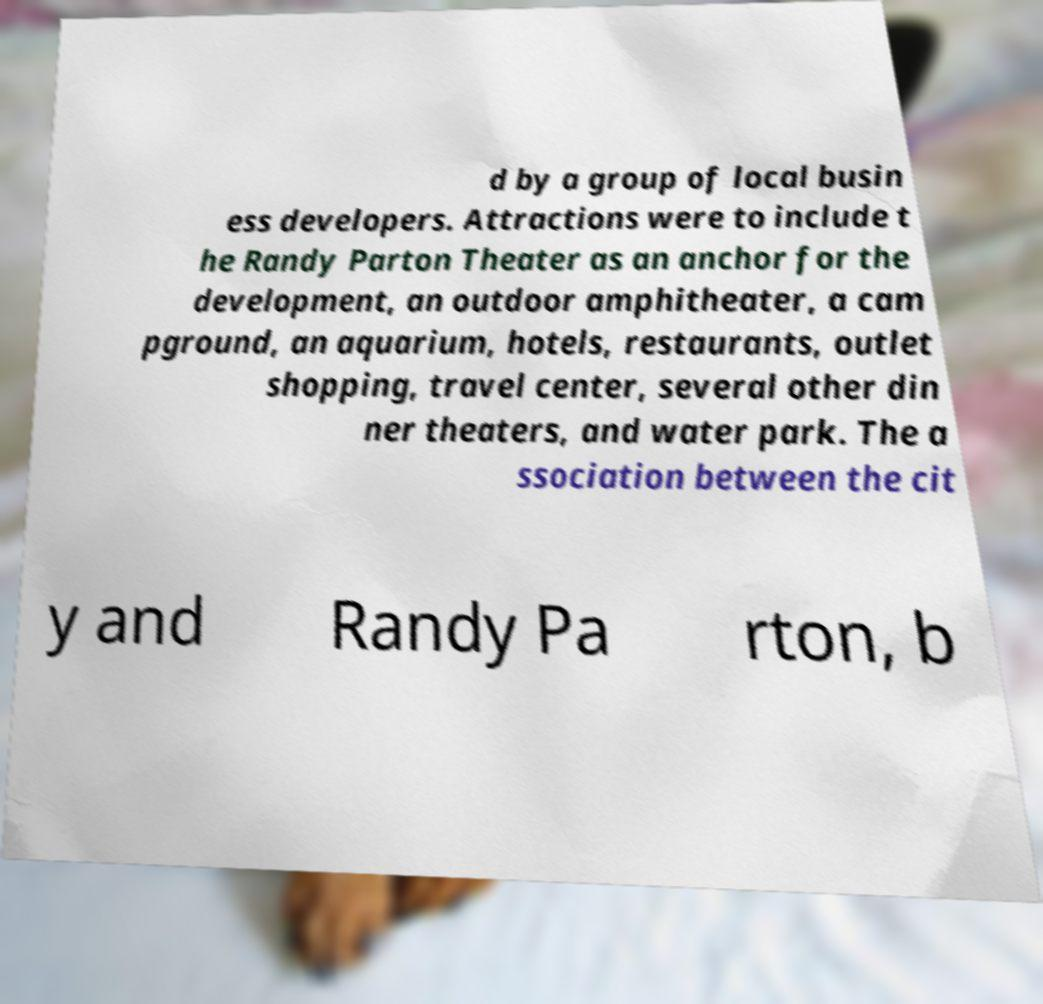What messages or text are displayed in this image? I need them in a readable, typed format. d by a group of local busin ess developers. Attractions were to include t he Randy Parton Theater as an anchor for the development, an outdoor amphitheater, a cam pground, an aquarium, hotels, restaurants, outlet shopping, travel center, several other din ner theaters, and water park. The a ssociation between the cit y and Randy Pa rton, b 